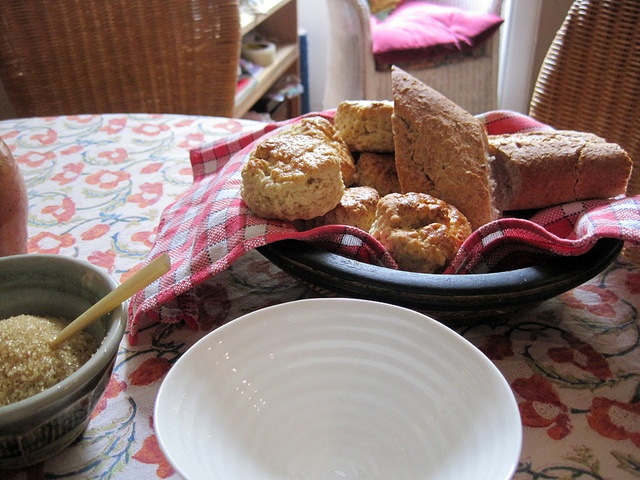Describe the objects in this image and their specific colors. I can see dining table in maroon, darkgray, black, and lightgray tones, bowl in maroon, darkgray, and lightgray tones, bowl in maroon, darkgray, and lightgray tones, chair in maroon, black, and lavender tones, and bowl in maroon, black, gray, and tan tones in this image. 